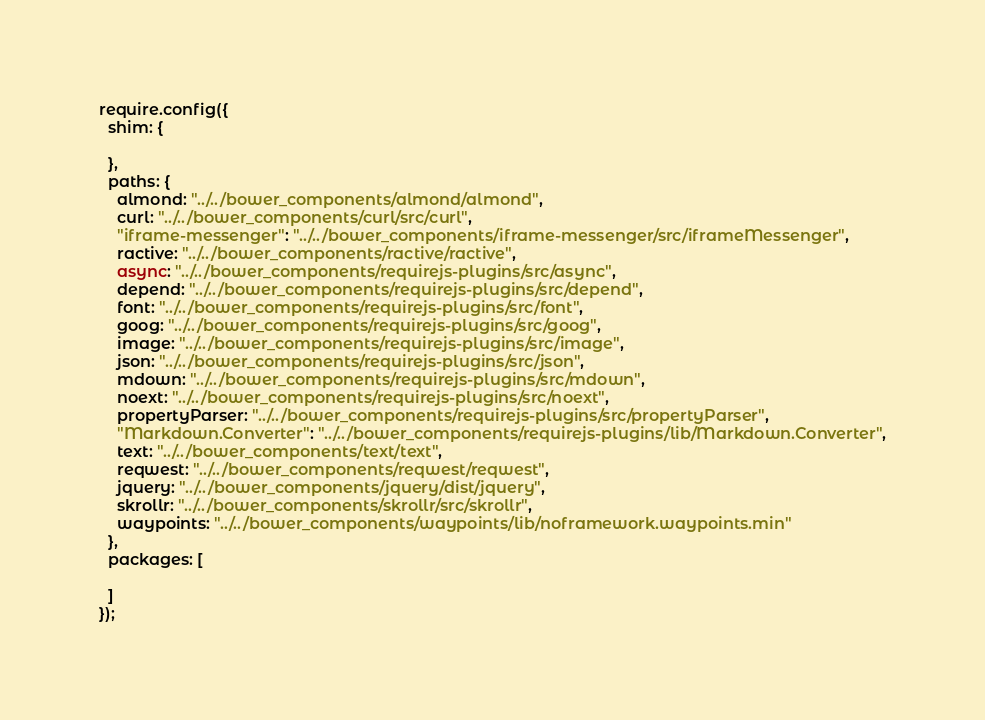Convert code to text. <code><loc_0><loc_0><loc_500><loc_500><_JavaScript_>require.config({
  shim: {

  },
  paths: {
    almond: "../../bower_components/almond/almond",
    curl: "../../bower_components/curl/src/curl",
    "iframe-messenger": "../../bower_components/iframe-messenger/src/iframeMessenger",
    ractive: "../../bower_components/ractive/ractive",
    async: "../../bower_components/requirejs-plugins/src/async",
    depend: "../../bower_components/requirejs-plugins/src/depend",
    font: "../../bower_components/requirejs-plugins/src/font",
    goog: "../../bower_components/requirejs-plugins/src/goog",
    image: "../../bower_components/requirejs-plugins/src/image",
    json: "../../bower_components/requirejs-plugins/src/json",
    mdown: "../../bower_components/requirejs-plugins/src/mdown",
    noext: "../../bower_components/requirejs-plugins/src/noext",
    propertyParser: "../../bower_components/requirejs-plugins/src/propertyParser",
    "Markdown.Converter": "../../bower_components/requirejs-plugins/lib/Markdown.Converter",
    text: "../../bower_components/text/text",
    reqwest: "../../bower_components/reqwest/reqwest",
    jquery: "../../bower_components/jquery/dist/jquery",
    skrollr: "../../bower_components/skrollr/src/skrollr",
    waypoints: "../../bower_components/waypoints/lib/noframework.waypoints.min"
  },
  packages: [

  ]
});
</code> 